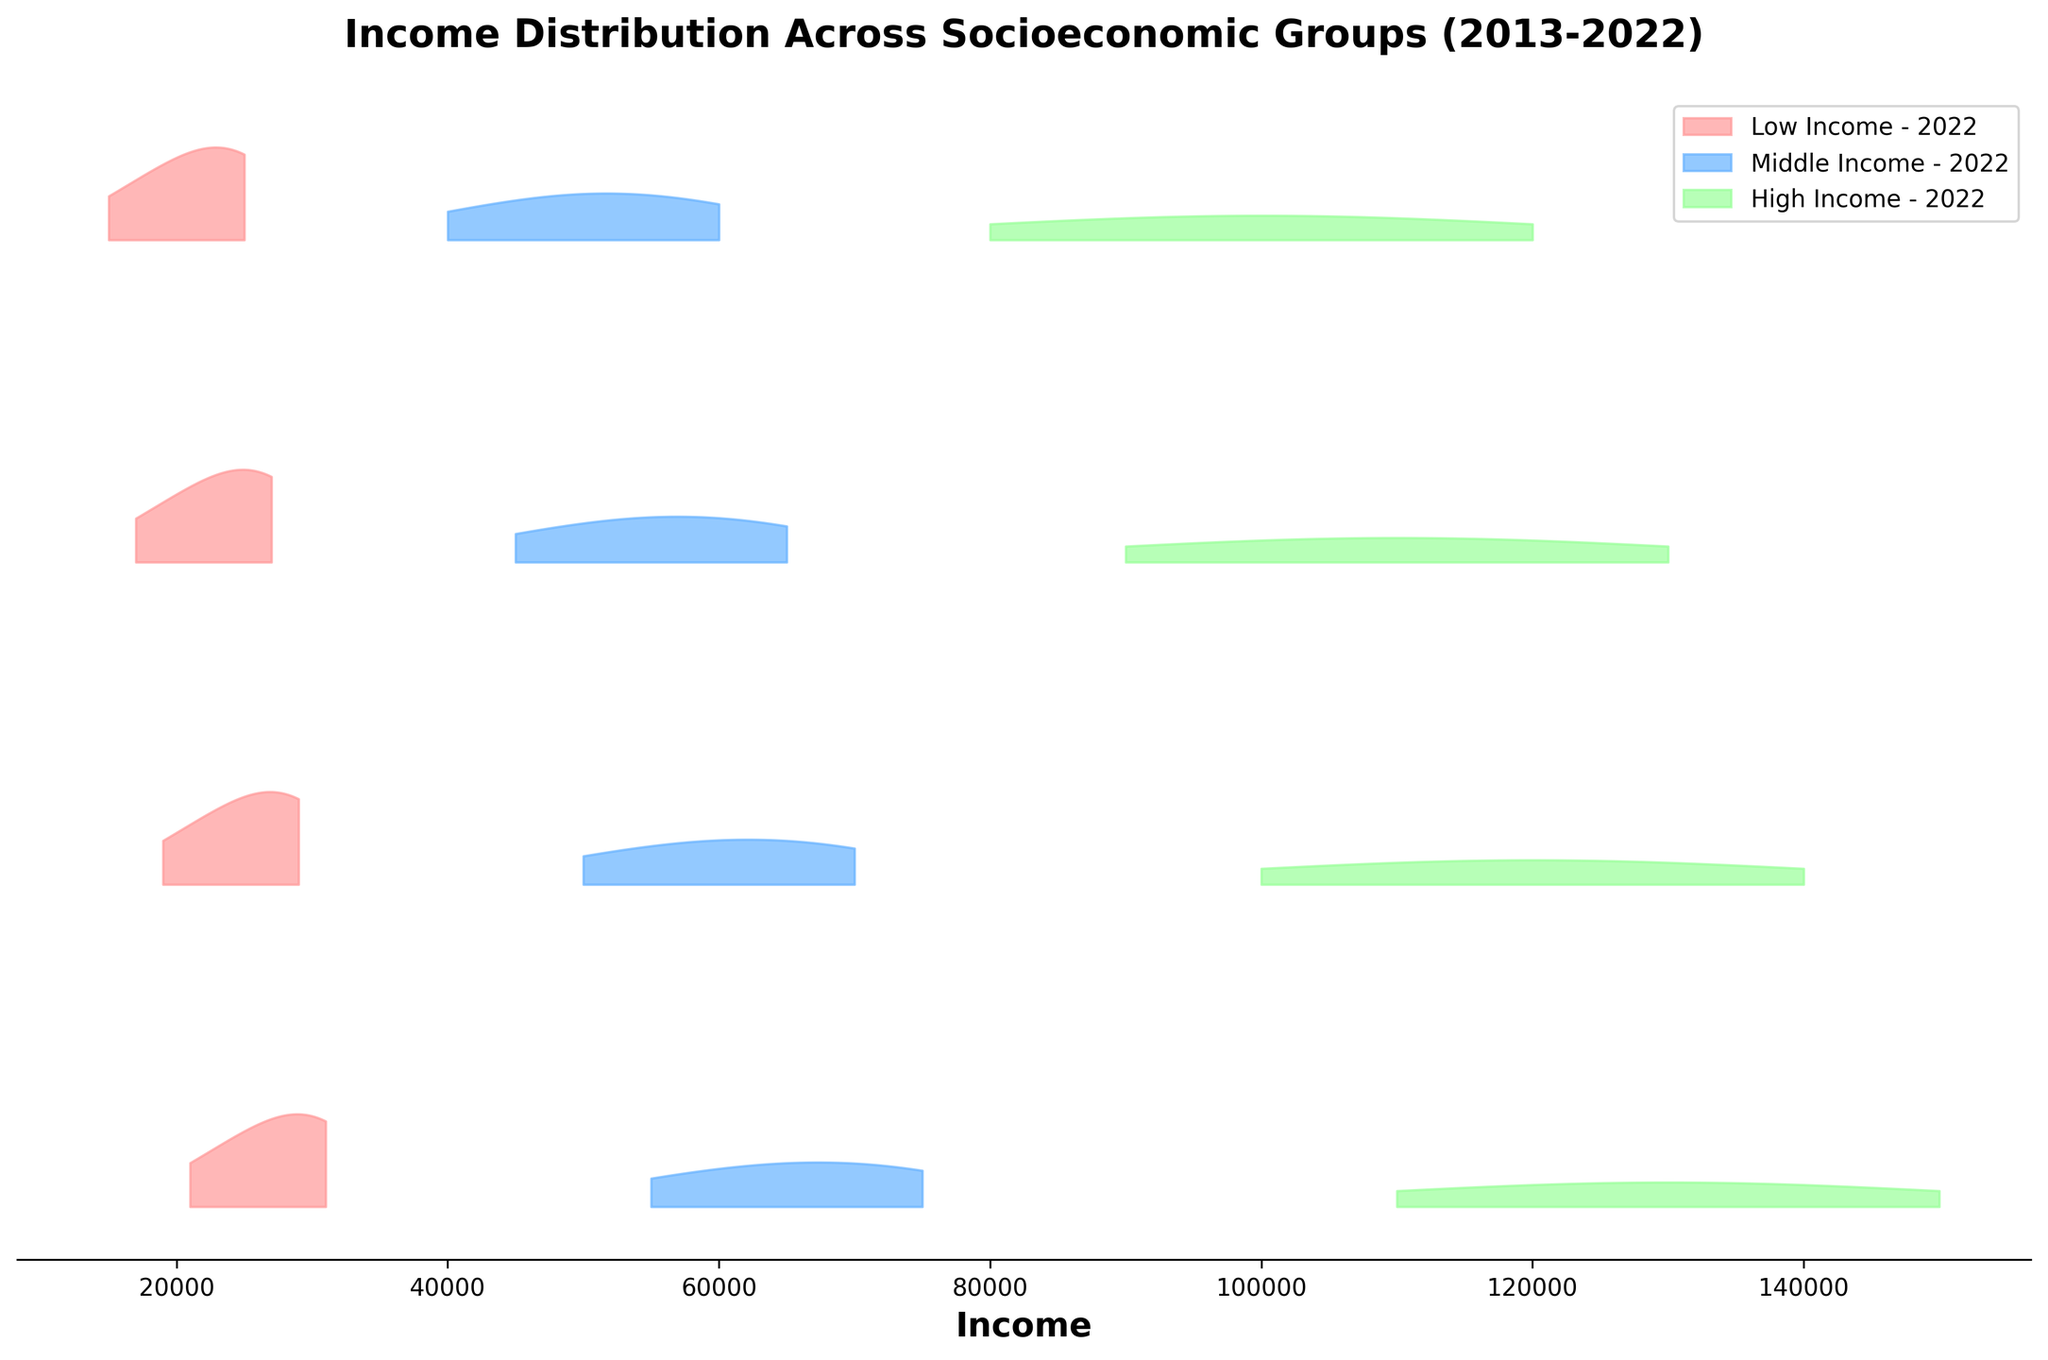What is the title of the figure? The title is typically found at the top of the figure and provides a summary of what the plot is about. The title reads "Income Distribution Across Socioeconomic Groups (2013-2022)."
Answer: Income Distribution Across Socioeconomic Groups (2013-2022) What does the x-axis represent in the plot? The x-axis is labeled "Income" in the figure, indicating that it represents various income levels in the dataset.
Answer: Income Which group has the highest density of income in 2022? To find the group with the highest density in 2022, look for the peak that is highest in the y-direction for the year 2022. The Middle Income group has the highest peak density in 2022.
Answer: Middle Income How has the income range for Low Income groups changed from 2013 to 2022? By examining the spread of the x-axis values for the Low Income group from 2013 to 2022, the income range has increased from 15,000-25,000 in 2013 to 21,000-31,000 in 2022.
Answer: Increased Which year has the highest peak density for the Middle Income group? To determine this, compare the heights of the peaks for the Middle Income group across all years. The year 2022 has the highest peak density for the Middle Income group.
Answer: 2022 Among the years 2013, 2016, 2019, and 2022, which group experienced the least change in income distribution? To find this, compare the income ranges and densities for each group over the years. The High Income group shows the least change in income distribution across these years.
Answer: High Income Compare the density peaks of Low Income group between 2013 and 2019. What change is observed? Examine the height of the density peaks for the Low Income group in 2013 and 2019. The density peak for Low Income group has increased from 0.00015 in 2013 to 0.00021 in 2019, indicating an increased density.
Answer: Increased density What is the color used for the Middle Income group in the plot? The colors are used to differentiate between different groups. The Middle Income group is represented with a blue color in the plot.
Answer: Blue 